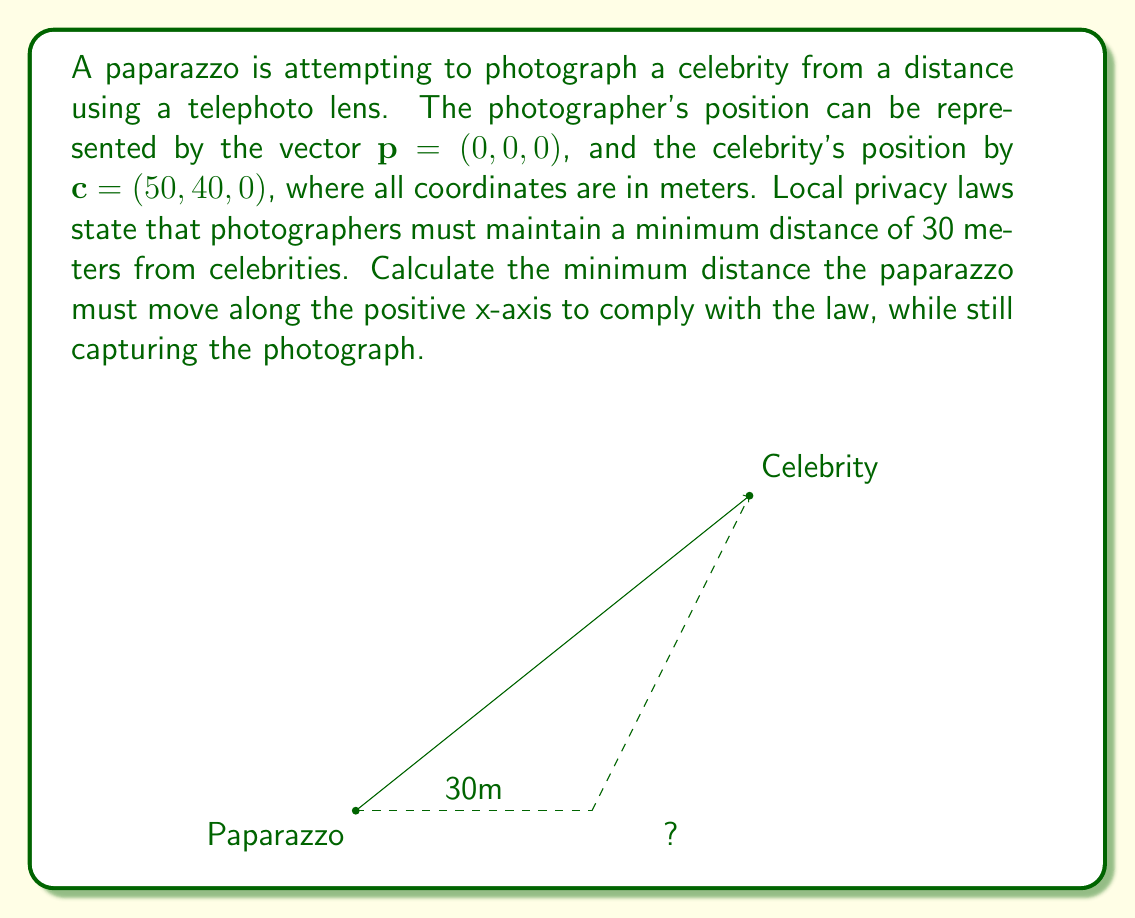Can you solve this math problem? Let's approach this step-by-step:

1) The current distance between the paparazzo and the celebrity can be calculated using the distance formula in 3D space:

   $$d = \sqrt{(x_2-x_1)^2 + (y_2-y_1)^2 + (z_2-z_1)^2}$$
   $$d = \sqrt{(50-0)^2 + (40-0)^2 + (0-0)^2} = \sqrt{2500 + 1600} = \sqrt{4100} \approx 64.03 \text{ meters}$$

2) The paparazzo needs to move along the x-axis. Let's call this distance $x$. After moving, the new position of the paparazzo will be $(x, 0, 0)$.

3) The new distance between the paparazzo and the celebrity should be exactly 30 meters (the minimum allowed). We can set up an equation:

   $$30^2 = (50-x)^2 + 40^2 + 0^2$$

4) Simplify:
   $$900 = (50-x)^2 + 1600$$
   $$900 = 2500 - 100x + x^2 + 1600$$
   $$x^2 - 100x - 3200 = 0$$

5) This is a quadratic equation. We can solve it using the quadratic formula:
   $$x = \frac{-b \pm \sqrt{b^2 - 4ac}}{2a}$$
   where $a=1$, $b=-100$, and $c=-3200$

6) Solving:
   $$x = \frac{100 \pm \sqrt{10000 + 12800}}{2} = \frac{100 \pm \sqrt{22800}}{2}$$
   $$x = \frac{100 \pm 150.997}{2}$$

7) This gives us two solutions: $x \approx 125.499$ or $x \approx -25.499$

8) Since we're asked for the minimum distance along the positive x-axis, we choose the positive solution.

9) The minimum distance the paparazzo must move is:
   $$125.499 - 0 = 125.499 \text{ meters}$$
Answer: $125.499 \text{ meters}$ 